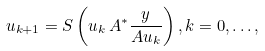Convert formula to latex. <formula><loc_0><loc_0><loc_500><loc_500>u _ { k + 1 } = S \left ( u _ { k } \, A ^ { * } \frac { y } { A u _ { k } } \right ) , k = 0 , \dots ,</formula> 